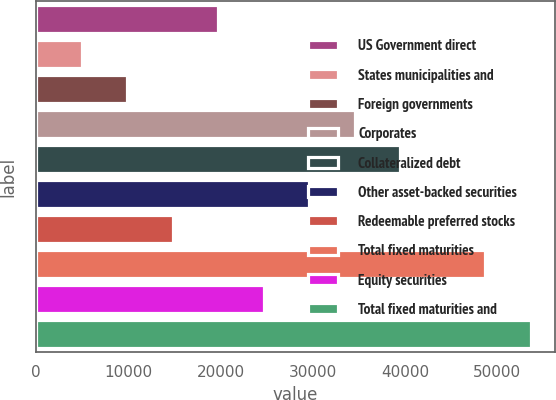<chart> <loc_0><loc_0><loc_500><loc_500><bar_chart><fcel>US Government direct<fcel>States municipalities and<fcel>Foreign governments<fcel>Corporates<fcel>Collateralized debt<fcel>Other asset-backed securities<fcel>Redeemable preferred stocks<fcel>Total fixed maturities<fcel>Equity securities<fcel>Total fixed maturities and<nl><fcel>19761<fcel>4940.56<fcel>9880.72<fcel>34581.5<fcel>39521.7<fcel>29641.4<fcel>14820.9<fcel>48692<fcel>24701.2<fcel>53632.2<nl></chart> 